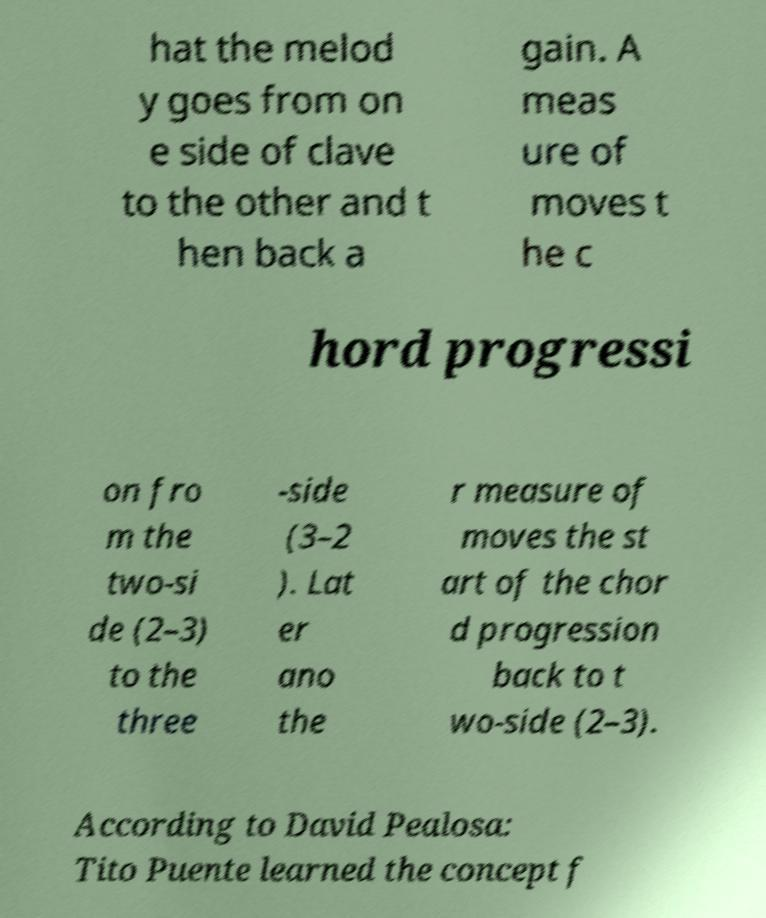Could you assist in decoding the text presented in this image and type it out clearly? hat the melod y goes from on e side of clave to the other and t hen back a gain. A meas ure of moves t he c hord progressi on fro m the two-si de (2–3) to the three -side (3–2 ). Lat er ano the r measure of moves the st art of the chor d progression back to t wo-side (2–3). According to David Pealosa: Tito Puente learned the concept f 